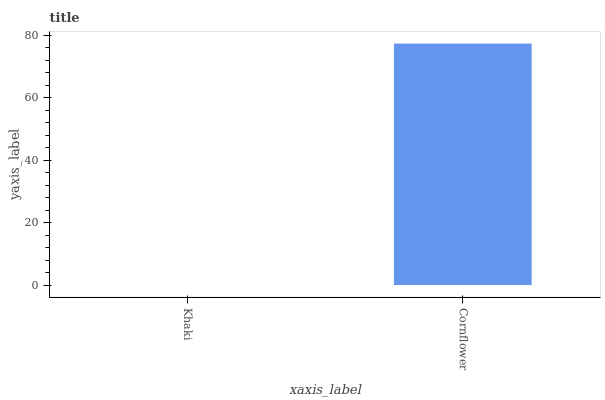Is Khaki the minimum?
Answer yes or no. Yes. Is Cornflower the maximum?
Answer yes or no. Yes. Is Cornflower the minimum?
Answer yes or no. No. Is Cornflower greater than Khaki?
Answer yes or no. Yes. Is Khaki less than Cornflower?
Answer yes or no. Yes. Is Khaki greater than Cornflower?
Answer yes or no. No. Is Cornflower less than Khaki?
Answer yes or no. No. Is Cornflower the high median?
Answer yes or no. Yes. Is Khaki the low median?
Answer yes or no. Yes. Is Khaki the high median?
Answer yes or no. No. Is Cornflower the low median?
Answer yes or no. No. 